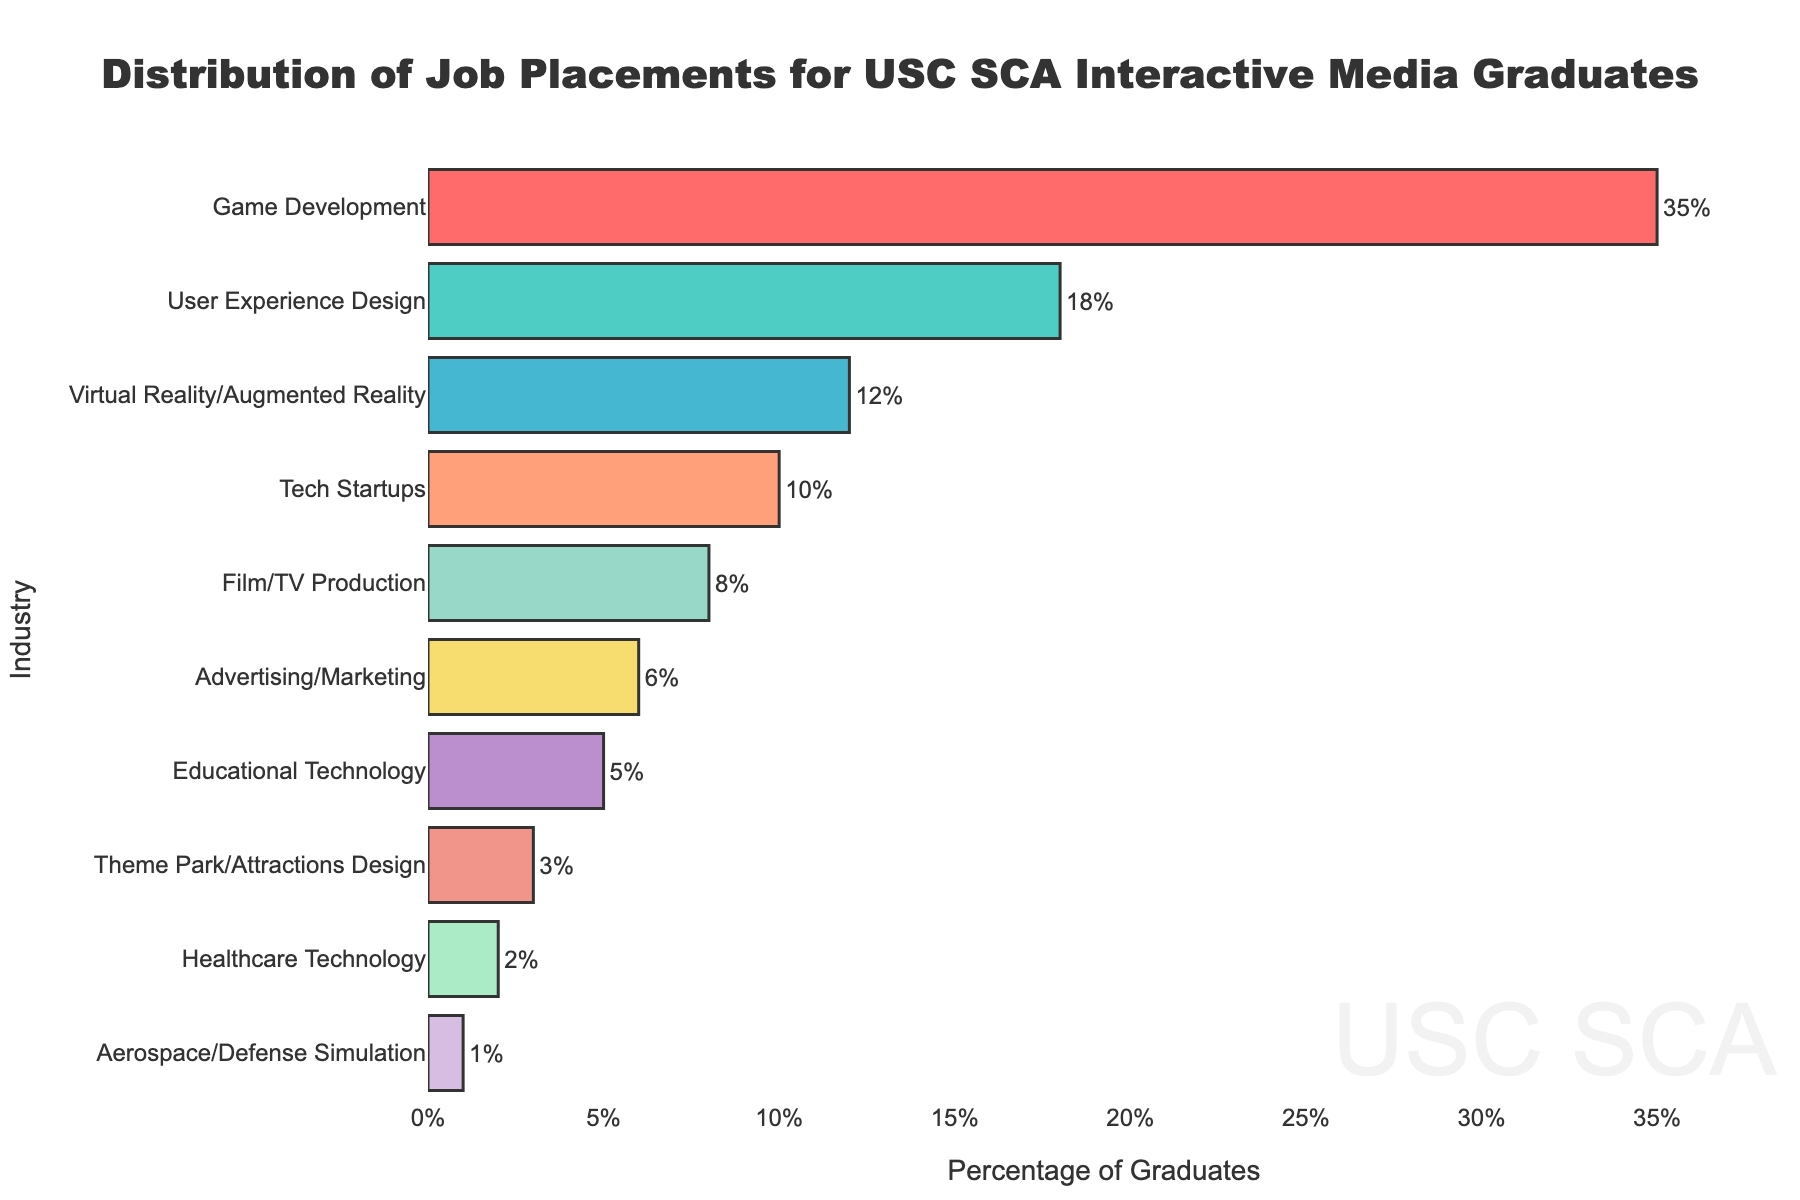Which industry has the highest percentage of job placements for USC SCA Interactive Media graduates? The game development bar is the longest, indicating the highest percentage.
Answer: Game Development Which industry has the lowest percentage of job placements? The aerospace/defense simulation bar is the shortest, indicating the lowest percentage.
Answer: Aerospace/Defense Simulation What is the combined percentage of graduates working in user experience design and virtual reality/augmented reality? User Experience Design has 18% and Virtual Reality/Augmented Reality has 12%. Summing these gives 18% + 12% = 30%.
Answer: 30% How much more popular is game development compared to film/TV production? Game Development has 35% and Film/TV Production has 8%. The difference is 35% - 8% = 27%.
Answer: 27% What percentage of graduates are in industries other than game development, user experience design, and virtual reality/augmented reality? Total percentage of game development, user experience design, and virtual reality/augmented reality is 35% + 18% + 12% = 65%. Therefore, the remaining percentage is 100% - 65% = 35%.
Answer: 35% Which two industries have the closest percentages of job placements? Tech startups have 10% and film/TV production has 8%. The difference is 10% - 8% = 2%, which is the smallest difference between any two industries.
Answer: Tech Startups and Film/TV Production How does the percentage of graduates in educational technology compare to those in advertising/marketing? Educational Technology has 5%. Advertising/Marketing has 6%. 5% is 1 percentage point less than 6%.
Answer: 1 percentage point less What is the average percentage of graduates placed in game development, user experience design, and virtual reality/augmented reality? The total percentage for these three categories is 35% + 18% + 12% = 65%. The average is 65% / 3 = 21.67%.
Answer: 21.67% Is the percentage of graduates in theme park/attractions design greater than those in aerospace/defense simulation? Theme Park/Attractions Design has 3% and Aerospace/Defense Simulation has 1%. 3% is greater than 1%.
Answer: Yes Which industries have percentages below 10%? The bars for film/TV production (8%), advertising/marketing (6%), educational technology (5%), theme park/attractions design (3%), healthcare technology (2%), and aerospace/defense simulation (1%) are all below 10%.
Answer: Film/TV Production, Advertising/Marketing, Educational Technology, Theme Park/Attractions Design, Healthcare Technology, Aerospace/Defense Simulation 